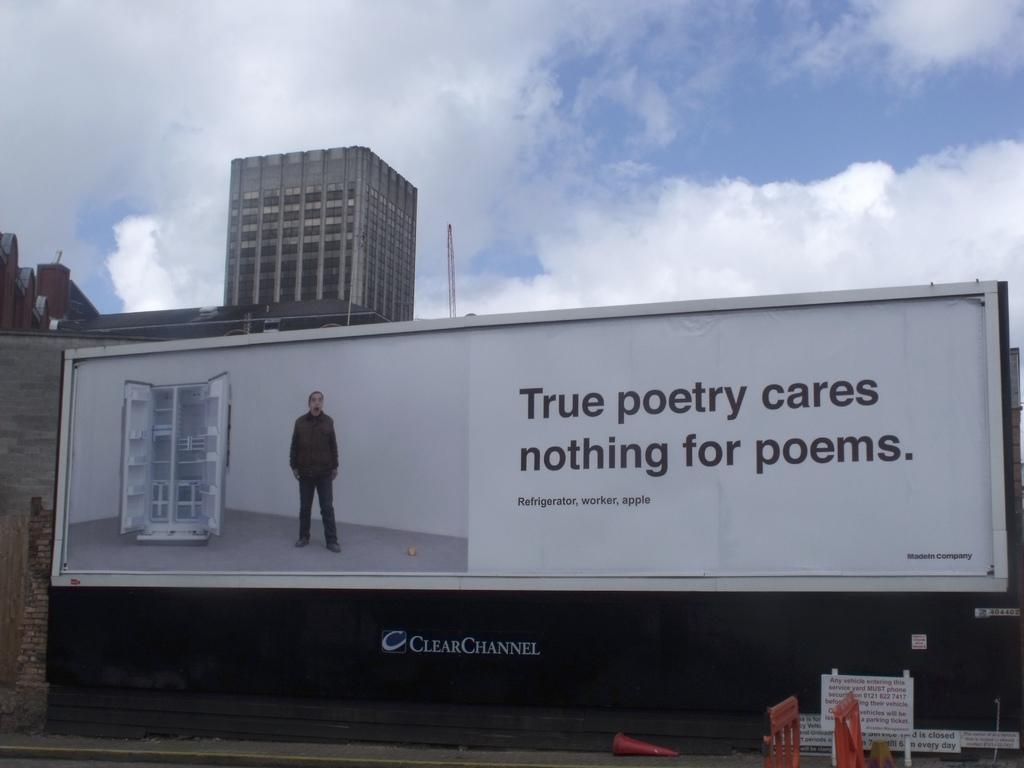In one or two sentences, can you explain what this image depicts? This image consists of a building. In the front, we can see a banner in which there is a fridge and a person along with the text. At the top, there are clouds in the sky. At the bottom, there is a pavement. 